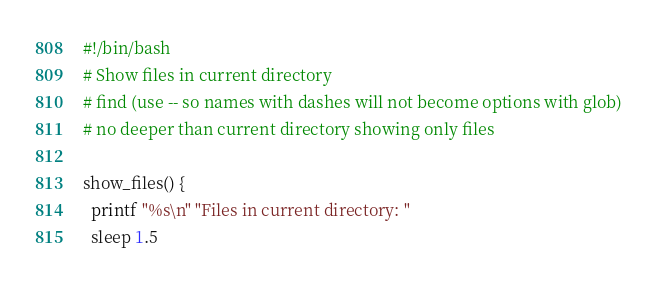<code> <loc_0><loc_0><loc_500><loc_500><_Bash_>#!/bin/bash
# Show files in current directory 
# find (use -- so names with dashes will not become options with glob)
# no deeper than current directory showing only files

show_files() { 
  printf "%s\n" "Files in current directory: " 
  sleep 1.5 
</code> 